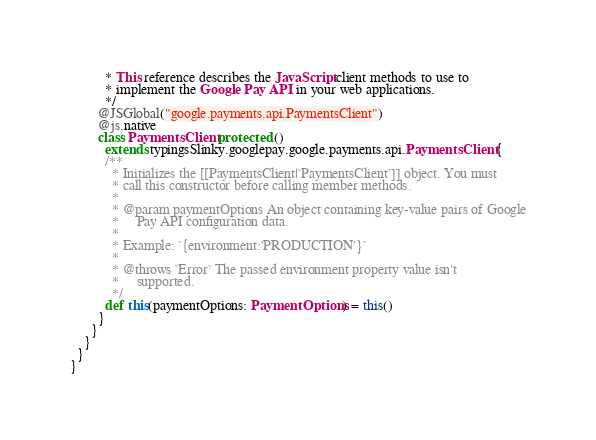<code> <loc_0><loc_0><loc_500><loc_500><_Scala_>          * This reference describes the JavaScript client methods to use to
          * implement the Google Pay API in your web applications.
          */
        @JSGlobal("google.payments.api.PaymentsClient")
        @js.native
        class PaymentsClient protected ()
          extends typingsSlinky.googlepay.google.payments.api.PaymentsClient {
          /**
            * Initializes the [[PaymentsClient|`PaymentsClient`]] object. You must
            * call this constructor before calling member methods.
            *
            * @param paymentOptions An object containing key-value pairs of Google
            *     Pay API configuration data.
            *
            * Example: `{environment:'PRODUCTION'}`
            *
            * @throws `Error` The passed environment property value isn't
            *     supported.
            */
          def this(paymentOptions: PaymentOptions) = this()
        }
      }
    }
  }
}
</code> 